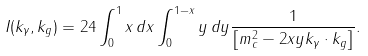Convert formula to latex. <formula><loc_0><loc_0><loc_500><loc_500>I ( k _ { \gamma } , k _ { g } ) = 2 4 \int _ { 0 } ^ { 1 } x \, d x \int _ { 0 } ^ { 1 - x } y \, d y \frac { 1 } { \left [ m _ { c } ^ { 2 } - 2 x y k _ { \gamma } \cdot k _ { g } \right ] } .</formula> 